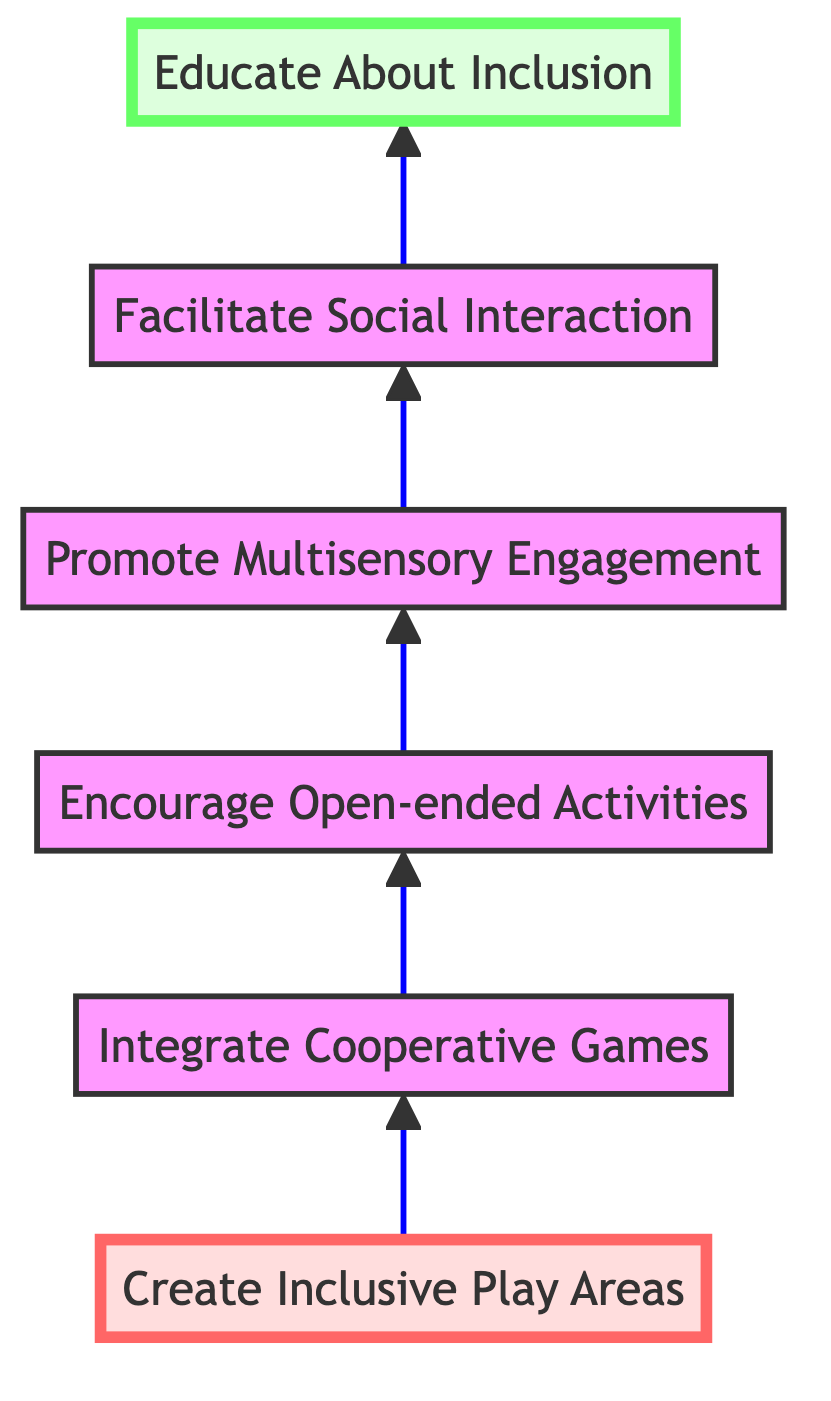What is the top-level node in this diagram? The top-level node is the final outcome of the flowchart, which can be found at the highest position. In this case, it is "Educate About Inclusion" as it is at the top and represents the ultimate goal of the flow.
Answer: Educate About Inclusion How many total nodes are there in the diagram? By counting each unique box or concept in the flowchart, we identify that there are six nodes present, from the first level to the last level.
Answer: 6 What is the connection between "Create Inclusive Play Areas" and "Integrate Cooperative Games"? The arrow indicating direction between these two nodes shows that "Create Inclusive Play Areas" leads into "Integrate Cooperative Games," meaning that creating inclusive areas is a precursor to integrating cooperative games in play.
Answer: Leads to What is the relationship between "Facilitate Social Interaction" and "Promote Multisensory Engagement"? The flow from "Promote Multisensory Engagement" to "Facilitate Social Interaction" indicates that engaging children across multiple senses is necessary before enhancing their social interactions, implying a sequential step in the process.
Answer: Sequential step What level is "Encourage Open-ended Activities"? The node "Encourage Open-ended Activities" can be identified by its position within the diagram between the nodes above and below. It is the third node in the sequence, therefore it is at level three.
Answer: Level 3 What concept is at the bottom of the flow chart? The bottom of the diagram highlights the foundational or starting point concept, which in this case is "Create Inclusive Play Areas," as it is the first step in the flow pointing upward.
Answer: Create Inclusive Play Areas How does "Promote Multisensory Engagement" impact "Facilitate Social Interaction"? The flow indication that "Promote Multisensory Engagement" directs to "Facilitate Social Interaction" suggests that enabling children to engage with multiple senses could enhance their ability to interact socially, demonstrating a positive impact.
Answer: Positive impact Which node emphasizes the importance of collaboration? Upon reviewing the diagram, the node specifically dedicated to fostering cooperation and teamwork amongst children is "Integrate Cooperative Games," as it explicitly mentions collaborative gameplay.
Answer: Integrate Cooperative Games 